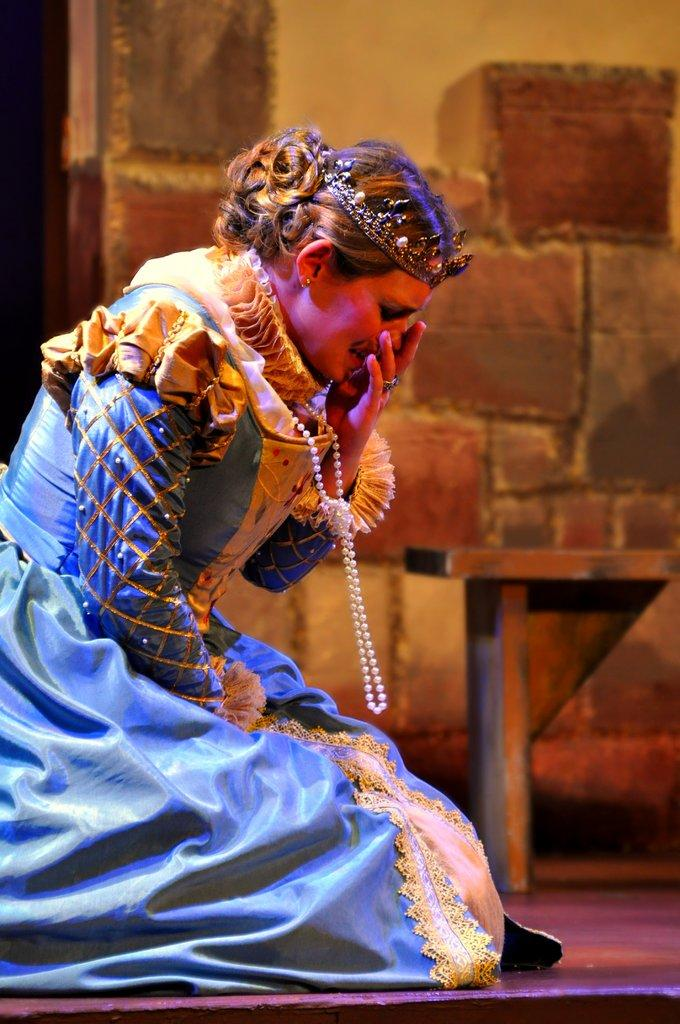Who is the main subject in the image? There is a woman in the image. What is the woman wearing? The woman is wearing a blue dress. What is the woman's position in the image? The woman appears to be sitting on the ground. What can be seen in the background of the image? There is a wall and other items visible in the background of the image. What type of fear can be seen on the woman's face in the image? There is no indication of fear on the woman's face in the image. Are there any bears visible in the image? No, there are no bears present in the image. 